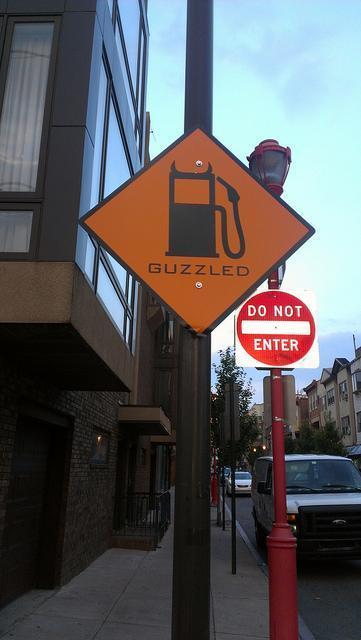How many stop signs are in the picture?
Give a very brief answer. 1. 